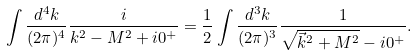Convert formula to latex. <formula><loc_0><loc_0><loc_500><loc_500>\int \frac { d ^ { 4 } k } { ( 2 \pi ) ^ { 4 } } \frac { i } { k ^ { 2 } - M ^ { 2 } + i 0 ^ { + } } = \frac { 1 } { 2 } \int \frac { d ^ { 3 } k } { ( 2 \pi ) ^ { 3 } } \frac { 1 } { \sqrt { \vec { k } ^ { 2 } + M ^ { 2 } } - i 0 ^ { + } } .</formula> 